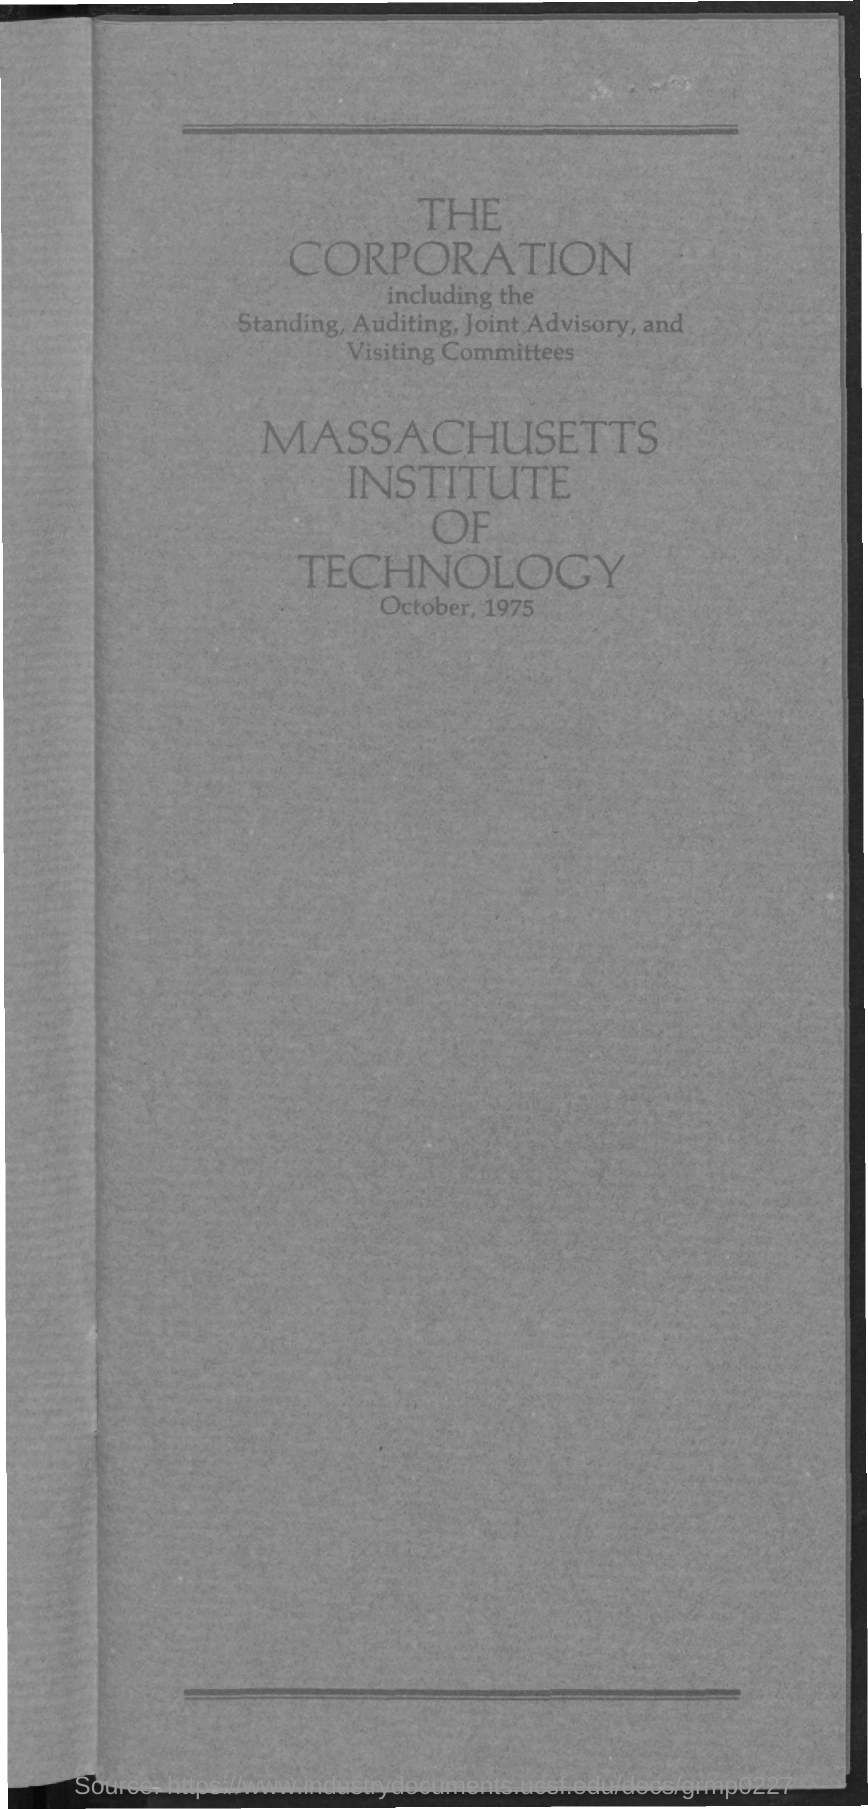Specify some key components in this picture. The Massachusetts Institute of Technology is mentioned in the text. 